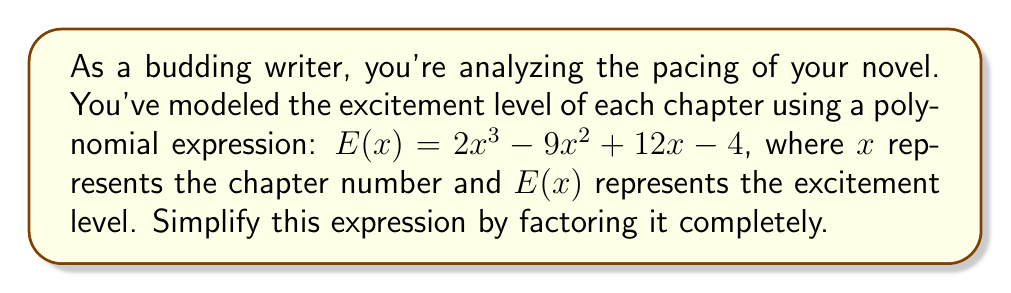Can you answer this question? Let's approach this step-by-step:

1) First, we'll check if there are any common factors. In this case, there are none.

2) Next, we'll try to factor by grouping. Let's rewrite the polynomial:

   $E(x) = 2x^3 - 9x^2 + 12x - 4$
   $E(x) = (2x^3 - 9x^2) + (12x - 4)$

3) Factor out the common factor from each group:

   $E(x) = x^2(2x - 9) + 4(3x - 1)$

4) Now, we can factor out $(2x - 3)$ from both terms:

   $E(x) = (2x - 3)(x^2 - 2)$

5) The second factor $(x^2 - 2)$ can be further factored using the difference of squares formula:

   $x^2 - 2 = (x + \sqrt{2})(x - \sqrt{2})$

6) Therefore, our final factored form is:

   $E(x) = (2x - 3)(x + \sqrt{2})(x - \sqrt{2})$

This factored form represents the simplified polynomial expression modeling the pacing of your novel.
Answer: $E(x) = (2x - 3)(x + \sqrt{2})(x - \sqrt{2})$ 